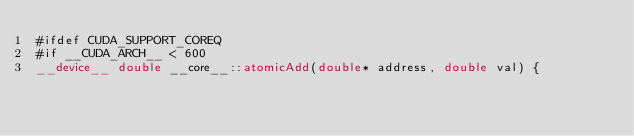<code> <loc_0><loc_0><loc_500><loc_500><_Cuda_>#ifdef CUDA_SUPPORT_COREQ
#if __CUDA_ARCH__ < 600
__device__ double __core__::atomicAdd(double* address, double val) {</code> 